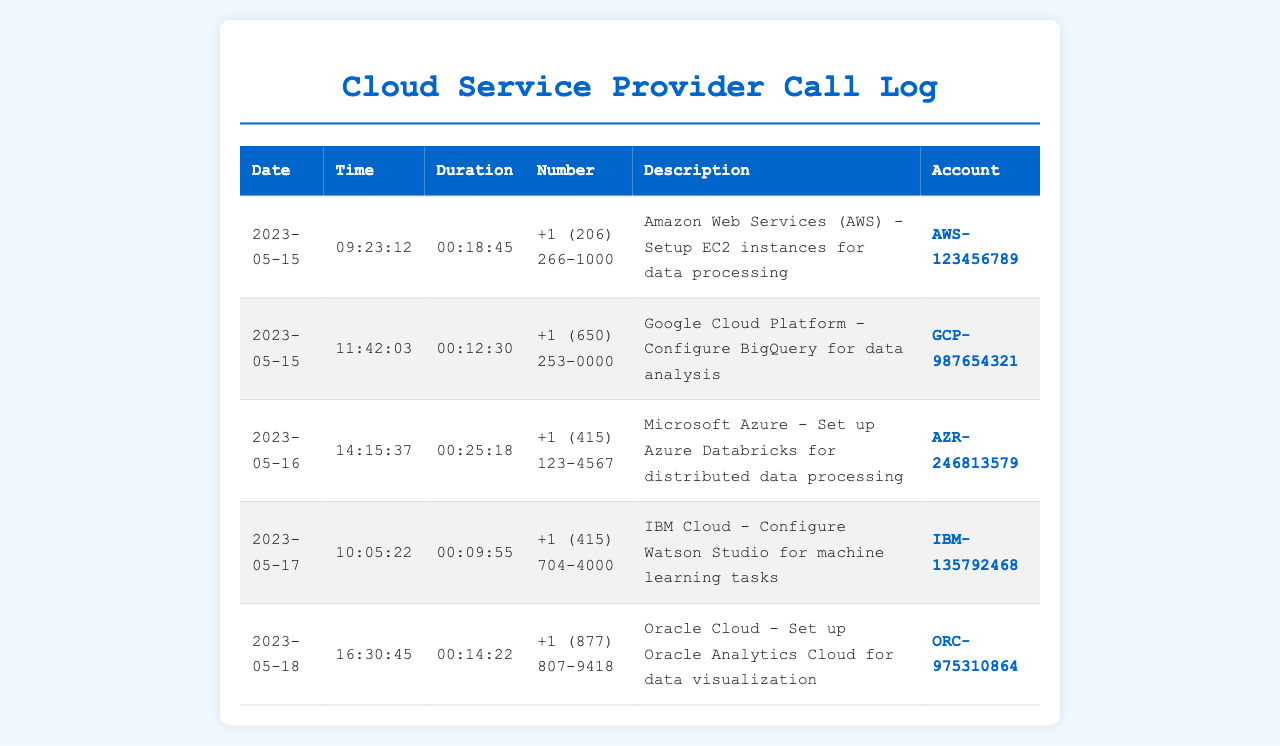what is the date of the call to Amazon Web Services? The call to Amazon Web Services occurred on May 15, 2023.
Answer: May 15, 2023 how long was the call to Google Cloud Platform? The duration of the call to Google Cloud Platform was recorded as 12 minutes and 30 seconds.
Answer: 00:12:30 which service was being set up in the call on May 16, 2023? The call on May 16, 2023, involved setting up Azure Databricks.
Answer: Azure Databricks what is the account number associated with IBM Cloud? The account number associated with IBM Cloud is presented in the log.
Answer: IBM-135792468 how many calls were made to cloud service providers on May 17, 2023? There was one call to a cloud service provider on May 17, 2023.
Answer: 1 what is the time of the call to Oracle Cloud? The time of the call to Oracle Cloud is given in the record.
Answer: 16:30:45 which cloud provider was called at 10:05:22? The provider called at that time was IBM Cloud.
Answer: IBM Cloud what is the description of the call made on May 18, 2023? The description of the call made on that date describes setting up Oracle Analytics Cloud for data visualization.
Answer: Set up Oracle Analytics Cloud for data visualization 